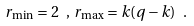Convert formula to latex. <formula><loc_0><loc_0><loc_500><loc_500>r _ { \min } = 2 \ , \, r _ { \max } = k ( q - k ) \ .</formula> 